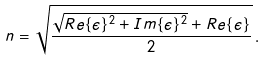Convert formula to latex. <formula><loc_0><loc_0><loc_500><loc_500>n = \sqrt { \frac { \sqrt { R e \{ \epsilon \} ^ { 2 } + I m \{ \epsilon \} ^ { 2 } } + R e \{ \epsilon \} } { 2 } } \, .</formula> 